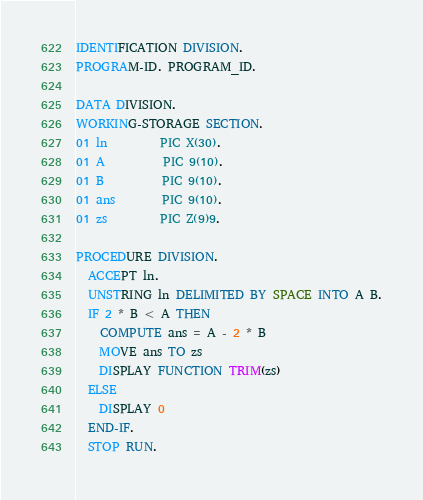Convert code to text. <code><loc_0><loc_0><loc_500><loc_500><_COBOL_>IDENTIFICATION DIVISION.
PROGRAM-ID. PROGRAM_ID.

DATA DIVISION.
WORKING-STORAGE SECTION.
01 ln         PIC X(30).
01 A          PIC 9(10).
01 B          PIC 9(10).
01 ans        PIC 9(10).
01 zs         PIC Z(9)9.

PROCEDURE DIVISION.
  ACCEPT ln.
  UNSTRING ln DELIMITED BY SPACE INTO A B.
  IF 2 * B < A THEN
    COMPUTE ans = A - 2 * B
    MOVE ans TO zs
    DISPLAY FUNCTION TRIM(zs)
  ELSE
    DISPLAY 0
  END-IF.
  STOP RUN.
</code> 